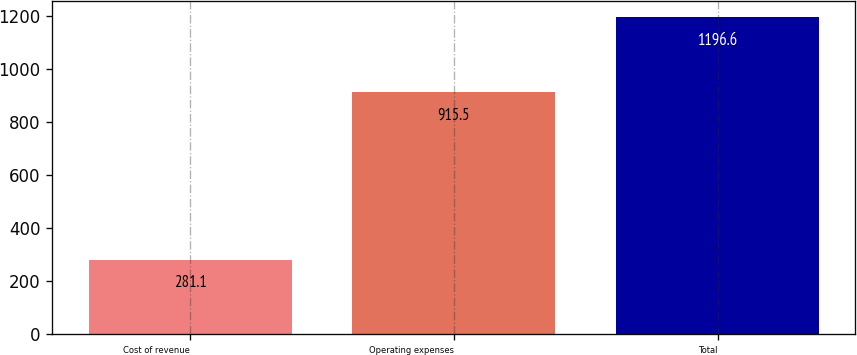Convert chart. <chart><loc_0><loc_0><loc_500><loc_500><bar_chart><fcel>Cost of revenue<fcel>Operating expenses<fcel>Total<nl><fcel>281.1<fcel>915.5<fcel>1196.6<nl></chart> 